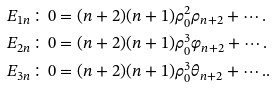Convert formula to latex. <formula><loc_0><loc_0><loc_500><loc_500>E _ { 1 n } & \colon 0 = ( n + 2 ) ( n + 1 ) \rho _ { 0 } ^ { 2 } \rho _ { n + 2 } + \cdots . \\ E _ { 2 n } & \colon 0 = ( n + 2 ) ( n + 1 ) \rho _ { 0 } ^ { 3 } \varphi _ { n + 2 } + \cdots . \\ E _ { 3 n } & \colon 0 = ( n + 2 ) ( n + 1 ) \rho _ { 0 } ^ { 3 } \theta _ { n + 2 } + \cdots . .</formula> 